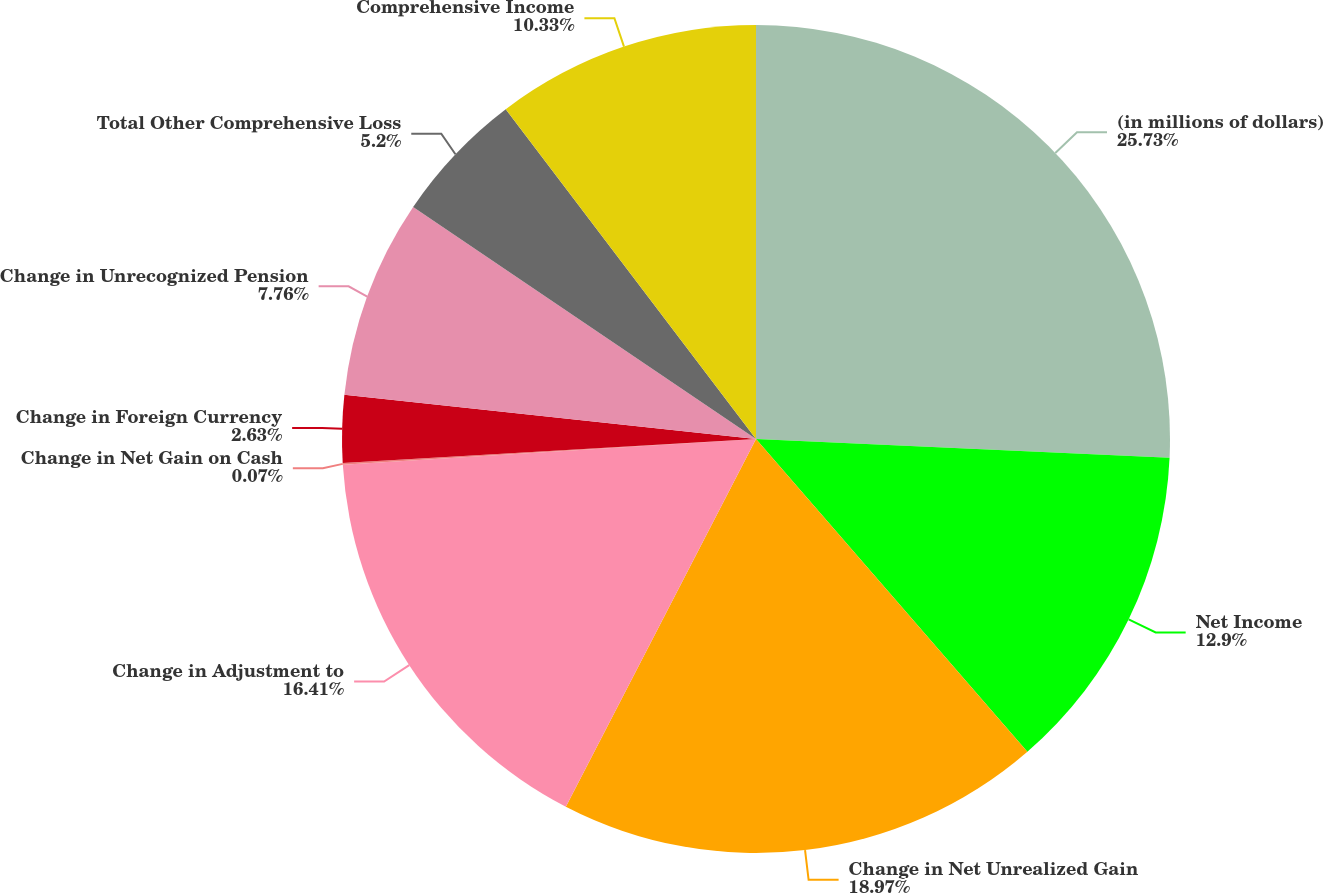<chart> <loc_0><loc_0><loc_500><loc_500><pie_chart><fcel>(in millions of dollars)<fcel>Net Income<fcel>Change in Net Unrealized Gain<fcel>Change in Adjustment to<fcel>Change in Net Gain on Cash<fcel>Change in Foreign Currency<fcel>Change in Unrecognized Pension<fcel>Total Other Comprehensive Loss<fcel>Comprehensive Income<nl><fcel>25.72%<fcel>12.9%<fcel>18.97%<fcel>16.41%<fcel>0.07%<fcel>2.63%<fcel>7.76%<fcel>5.2%<fcel>10.33%<nl></chart> 